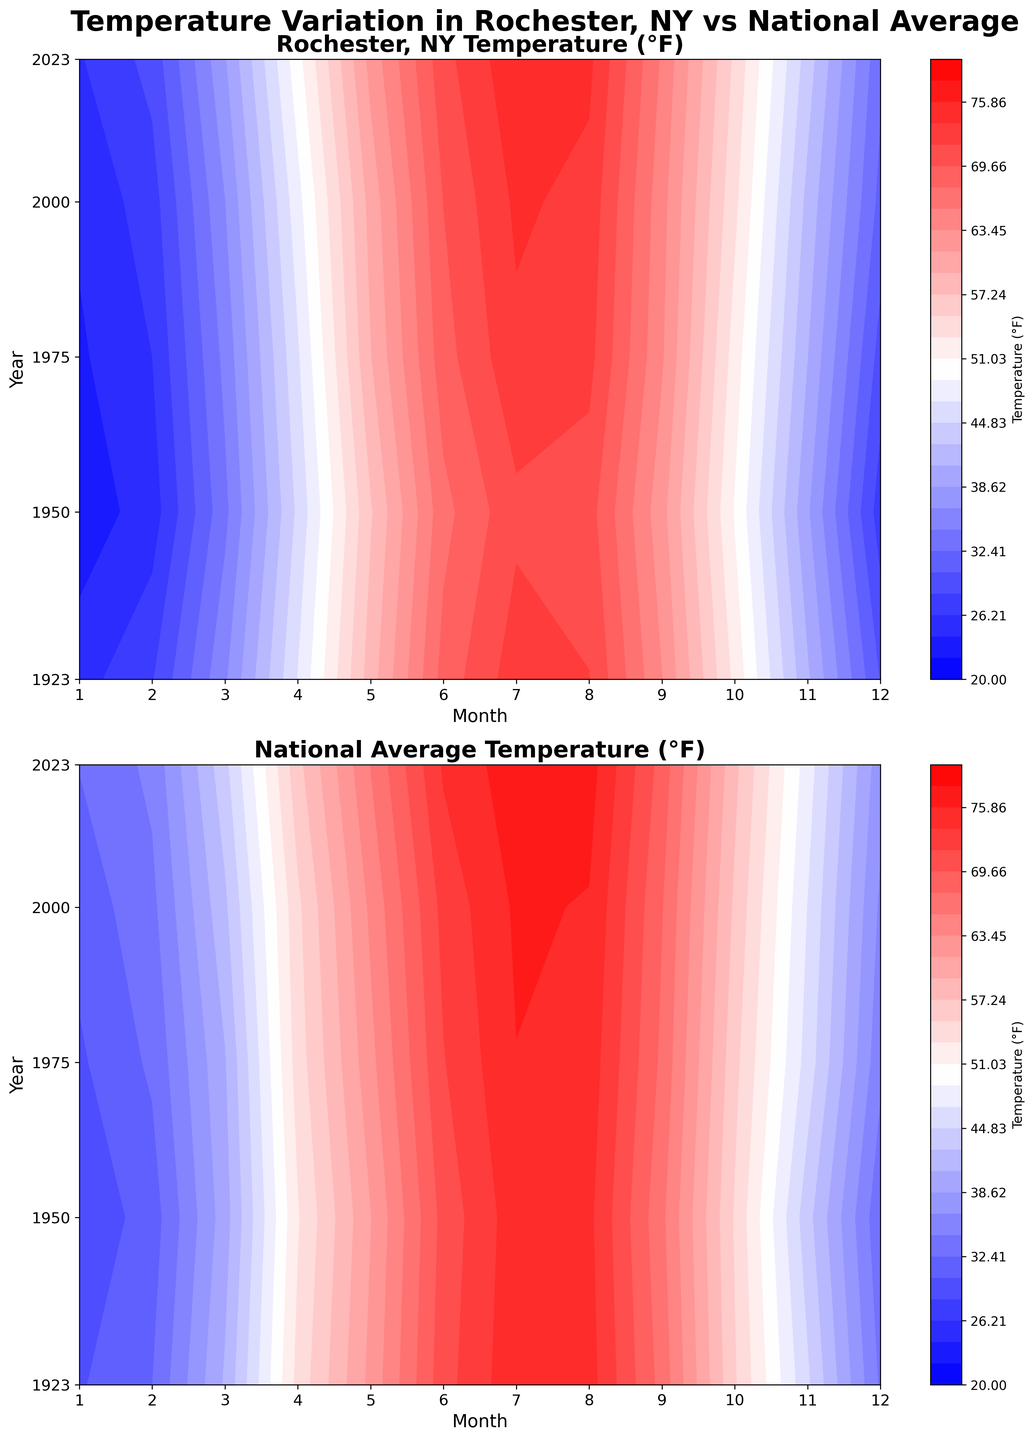What is the title of the first subplot? The title of the first subplot is located above it. The figure's overall title is "Temperature Variation in Rochester, NY vs National Average", and the title above the first subplot specifies "Rochester, NY Temperature (°F)".
Answer: Rochester, NY Temperature (°F) How are the x-axis and y-axis labeled in the second subplot? The second subplot has labeled axes. The x-axis is labeled "Month", and the y-axis is labeled "Year".
Answer: Month (x-axis), Year (y-axis) Which month shows the highest average temperature for Rochester, NY in 2023? By observing the highest value in the Rochester contour plot for the year 2023, July exhibits the highest average temperature, based on its peak in the color gradient, which corresponds to the temperature of 75.4°F.
Answer: July During which year did Rochester, NY have a significant increase in average temperature from December to January? To find the year with a significant temperature increase from December to January for Rochester, NY, examine the contour lines and color changes from December to January across all years. Notable differences occur during the years with marked color gradient changes.
Answer: 2000 How does the temperature in Rochester, NY compare to the national average in January 2023? By referring to both subplots for January 2023, the Rochester temperature is around 26°F, while the national average is roughly 32.5°F. Rochester is cooler than the national average that month.
Answer: Rochester is cooler In which year did the national average temperature in July reach approximately 77°F? Locate the color gradient corresponding to 77°F in the national average subplot and find the year where this color appears in July. The year 2023 meets this condition.
Answer: 2023 Across the years shown, does Rochester, NY typically have a higher average temperature than the national average in May? Comparing the contours for May across all years, the national average consistently appears slightly warmer than Rochester's temperatures in the same month.
Answer: No Identify a year when Rochester, NY had a similar average temperature to the national average in April. Check the April temperatures in both subplots and identify years where the contours align or show similar color gradients. In multiple years such as 1923 and 1975, the temperatures are comparable.
Answer: 1923, 1975 What is the approximate average temperature difference between Rochester, NY and the national average in November 1950? In November 1950, Rochester's average temperature is about 38.9°F, and the national average is around 43.5°F. Calculating the difference: 43.5 - 38.9 = 4.6°F.
Answer: 4.6°F Which year shows the coolest average temperatures nationally in January and how does it compare to Rochester, NY? To identify the coolest January national average, look for the coolest color shades in the national average subplot. The year 1950 shows the coolest national January temperature at approximately 28.7°F, compared to Rochester's 22.9°F in the same year. Rochester, NY is cooler than the national average in January 1950.
Answer: 1950, Rochester is cooler 